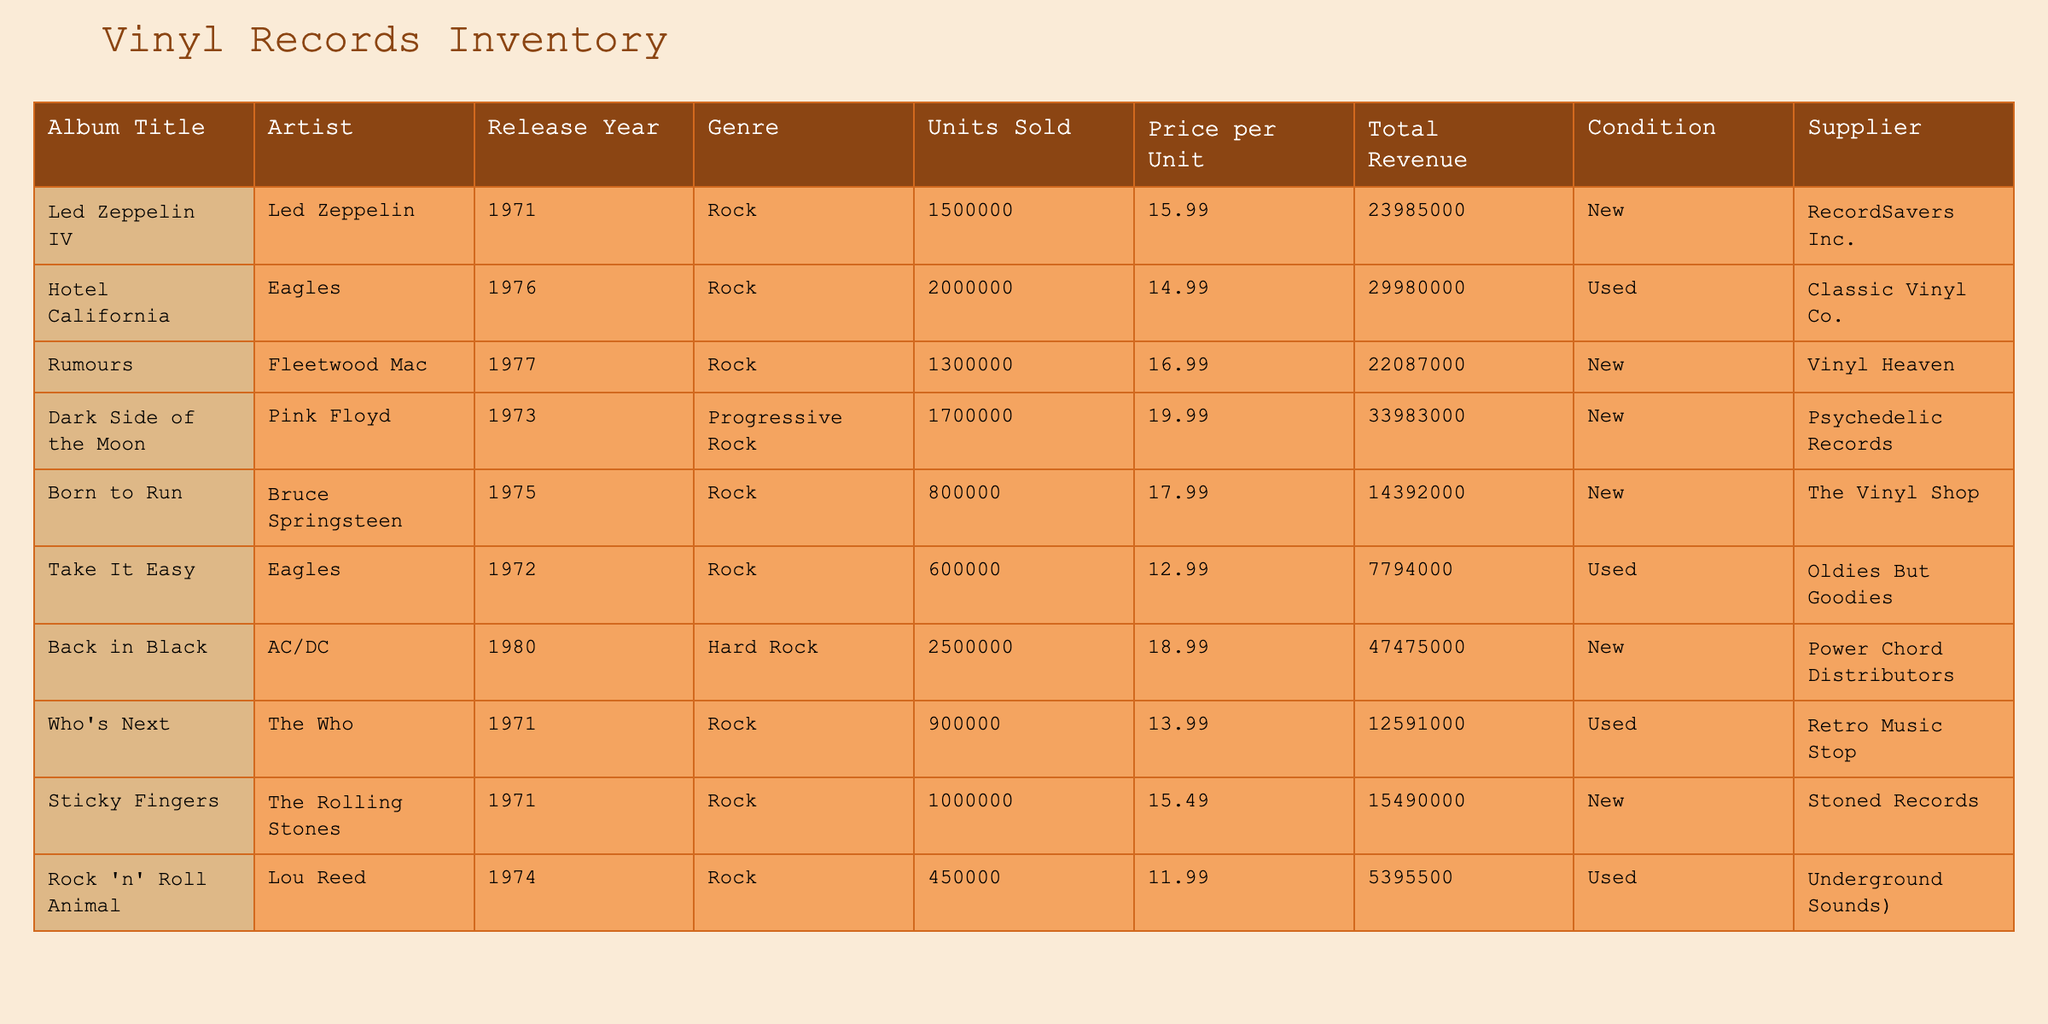What is the total revenue generated by "Hotel California"? The total revenue for "Hotel California" is already listed in the table under the "Total Revenue" column. It is shown as 29980000.
Answer: 29980000 What is the artist of the album "Born to Run"? The artist for "Born to Run" is found under the "Artist" column next to the album title in the table, which is Bruce Springsteen.
Answer: Bruce Springsteen Which album has the highest units sold? To determine the highest units sold, we compare the "Units Sold" values across all albums in the table. The highest value is for "Back in Black" with 2500000 units.
Answer: Back in Black What is the average price per unit of all listed albums? To find the average price per unit, we first sum the "Price per Unit" for all albums: (15.99 + 14.99 + 16.99 + 19.99 + 17.99 + 12.99 + 18.99 + 13.99 + 15.49 + 11.99) = 159.90. Then we divide by the number of albums, which is 10. The average price is 159.90 / 10 = 15.99.
Answer: 15.99 Is "Sticky Fingers" considered new or used? The condition of "Sticky Fingers" is indicated in the "Condition" column of the table. It shows "New," so it’s considered new.
Answer: Yes Which album is supplied by "Vinyl Heaven"? The supplier for "Vinyl Heaven" is associated with the album "Rumours" in the table. By referencing the supplier's name listed next to the album title, we confirm that it is indeed "Rumours."
Answer: Rumours What is the total revenue from used albums? For used albums, we look at the "Condition" column to identify "Used" entries: "Hotel California" (29980000) and "Take It Easy" (7794000). We sum these revenues: 29980000 + 7794000 = 37774000.
Answer: 37774000 Does "Dark Side of the Moon" have a higher revenue than "Rumours"? We compare their total revenues in the "Total Revenue" column. "Dark Side of the Moon" has 33983000 and "Rumours" has 22087000. Since 33983000 > 22087000, we conclude that "Dark Side of the Moon" does indeed have a higher revenue.
Answer: Yes How many more units were sold of "Led Zeppelin IV" compared to "Who's Next"? We find the units sold for each album: "Led Zeppelin IV" has 1500000 units and "Who's Next" has 900000 units. We calculate the difference: 1500000 - 900000 = 600000.
Answer: 600000 